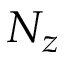Convert formula to latex. <formula><loc_0><loc_0><loc_500><loc_500>N _ { z }</formula> 